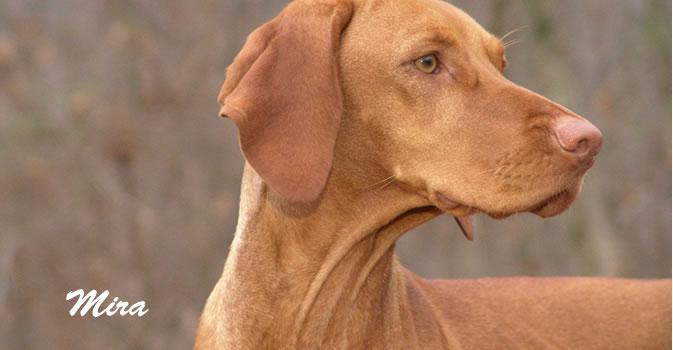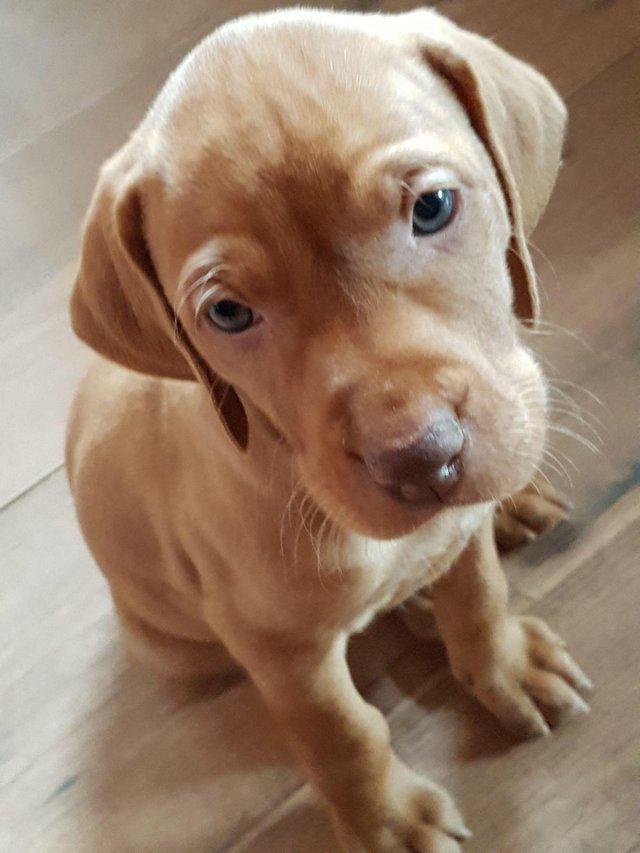The first image is the image on the left, the second image is the image on the right. Assess this claim about the two images: "The dog in the image on the left is lying down on a blue material.". Correct or not? Answer yes or no. No. The first image is the image on the left, the second image is the image on the right. Examine the images to the left and right. Is the description "The left and right image contains the same number of dogs and at least one is a puppy." accurate? Answer yes or no. Yes. 